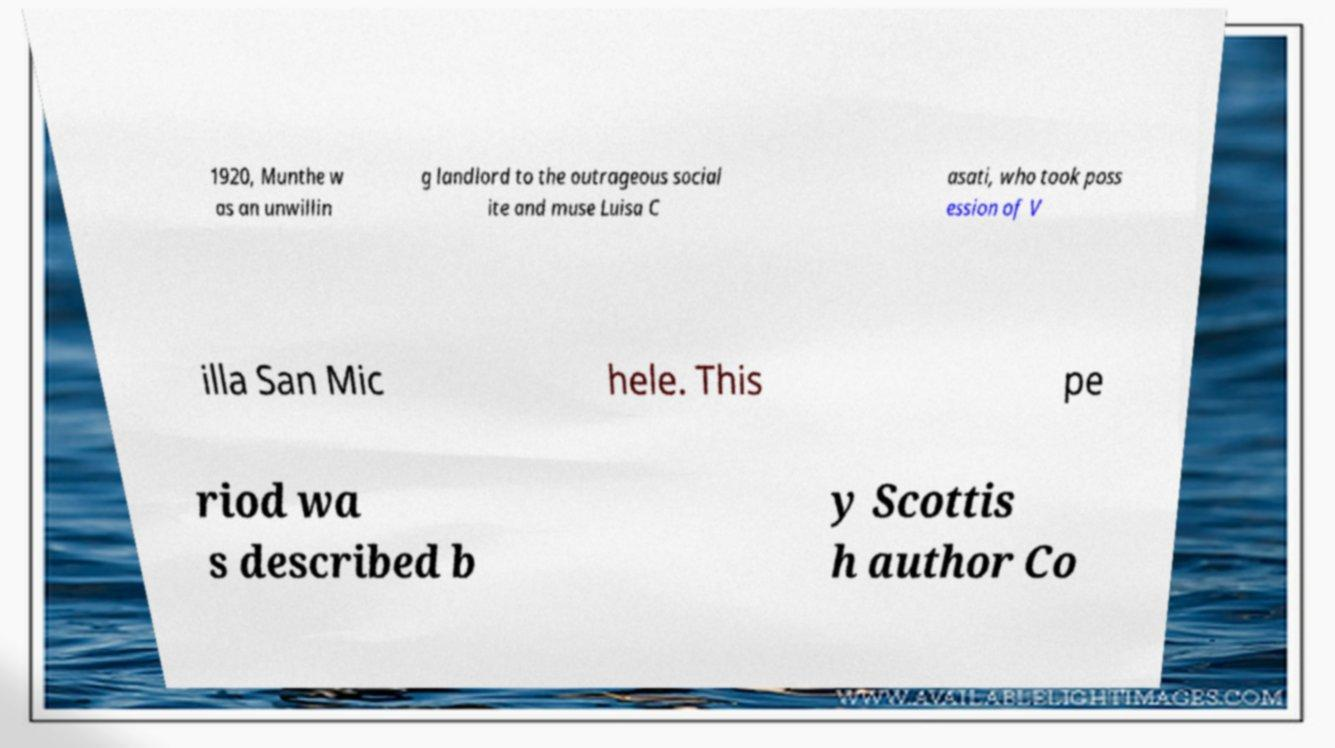There's text embedded in this image that I need extracted. Can you transcribe it verbatim? 1920, Munthe w as an unwillin g landlord to the outrageous social ite and muse Luisa C asati, who took poss ession of V illa San Mic hele. This pe riod wa s described b y Scottis h author Co 